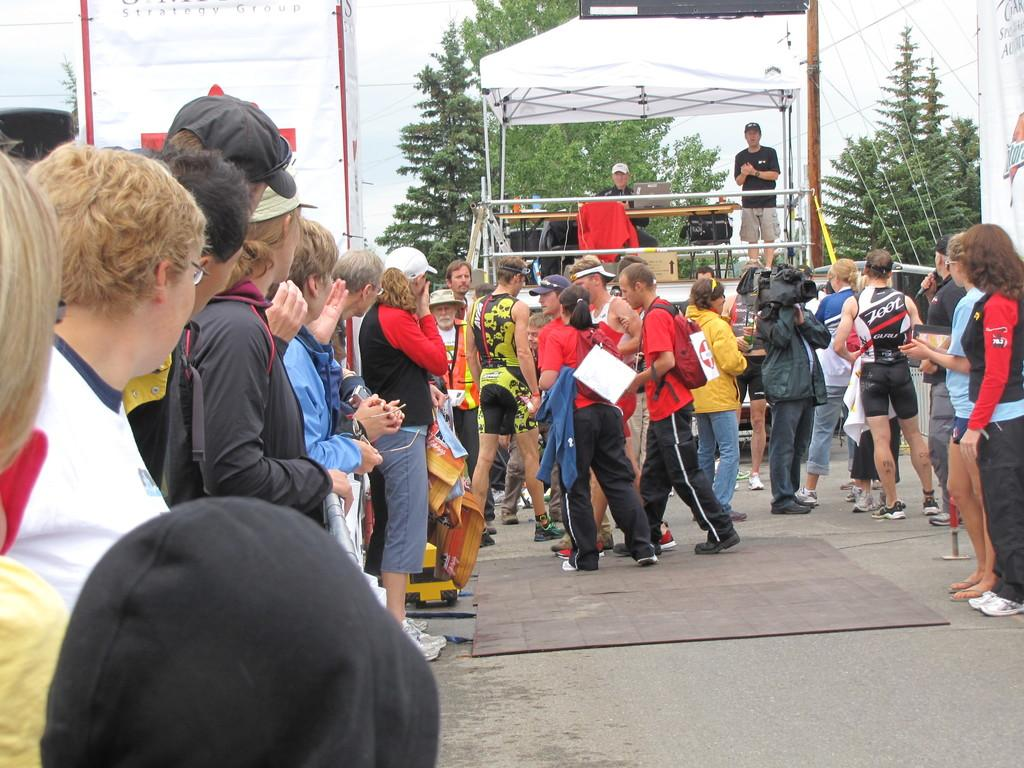What type of surface can be seen in the image? There is a road in the image. What type of flooring is present in the image? There is a carpet in the image. Can you describe the people in the image? There are people in the image. What is the main feature of the stage in the image? There is a stage in the image. What color is the object in the left background of the image? There is a white color object in the left background of the image. What is visible in the sky in the image? There is a sky visible in the image. What type of vegetation can be seen in the image? There are trees in the image. Can you tell me how many wrens are sitting on the carpet in the image? There are no wrens present in the image; it features a road, carpet, people, stage, white object, sky, and trees. What type of railway is visible in the image? There is no railway present in the image. 